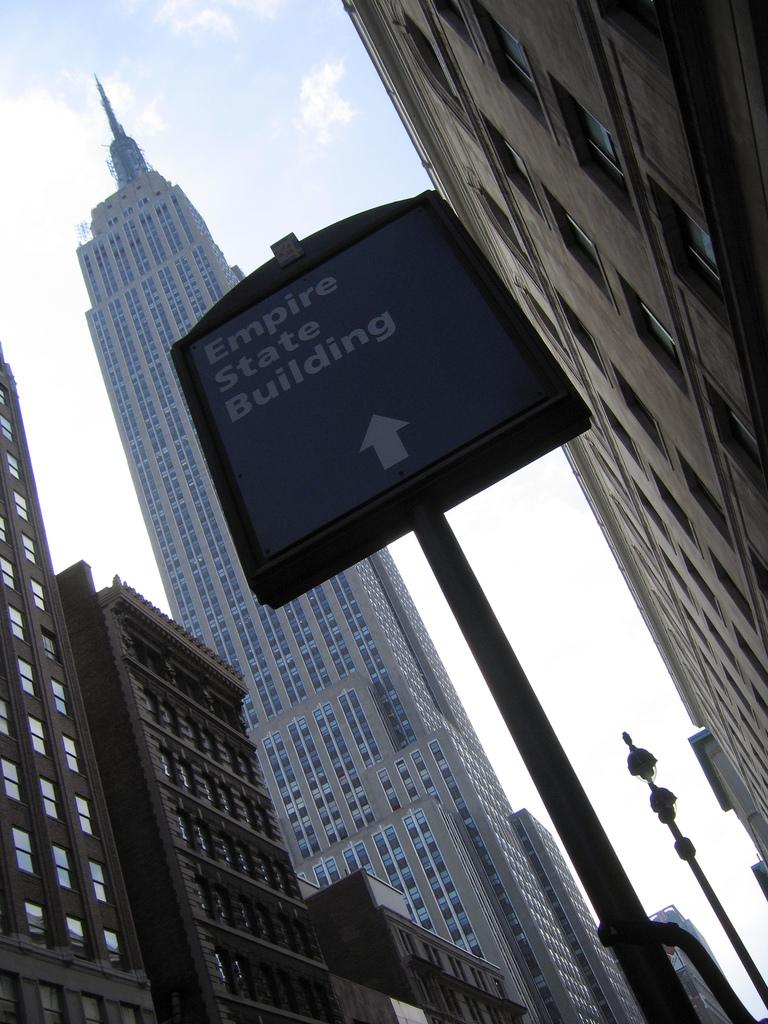What type of structures can be seen in the image? There are buildings in the image. How many windows are visible in the image? There are multiple windows visible in the image. What other objects can be seen in the image? There are poles in the image. What is visible in the sky in the image? Clouds are present in the image, and the sky is visible. What is on the board in the image? Something is written on the board in the image. What type of jam is being spread on the glass in the image? There is no jam or glass present in the image. What new idea is being discussed on the board in the image? The content of what is written on the board cannot be determined from the image. 